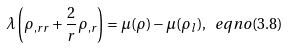<formula> <loc_0><loc_0><loc_500><loc_500>\lambda \left ( \rho _ { , r r } + \frac { 2 } { r } \rho _ { , r } \right ) = \mu ( \rho ) - \mu ( \rho _ { l } ) , \ e q n o ( 3 . 8 )</formula> 